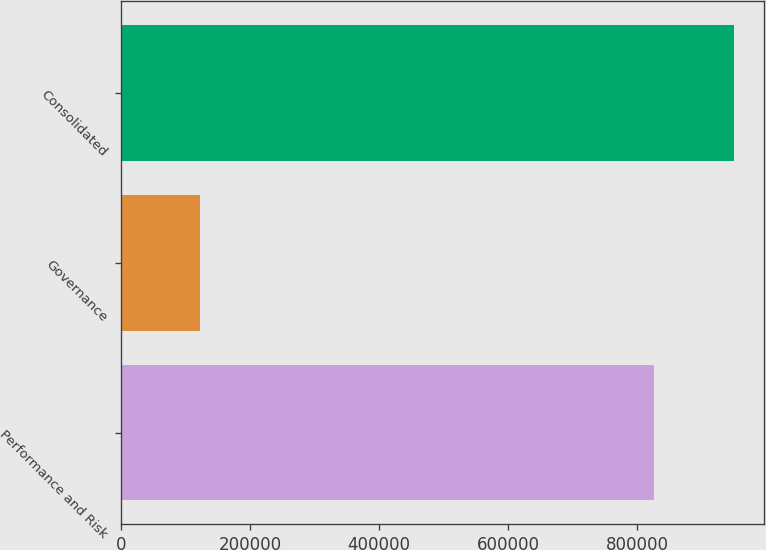Convert chart to OTSL. <chart><loc_0><loc_0><loc_500><loc_500><bar_chart><fcel>Performance and Risk<fcel>Governance<fcel>Consolidated<nl><fcel>826990<fcel>123151<fcel>950141<nl></chart> 